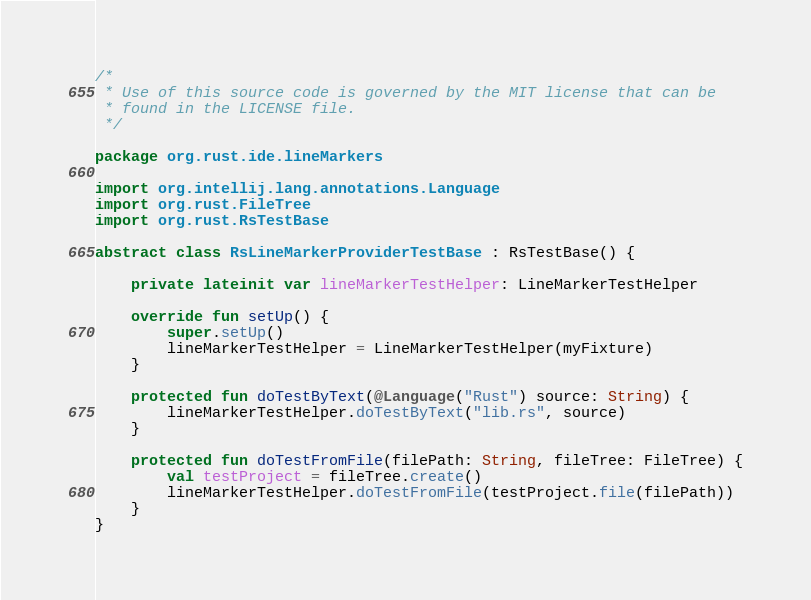Convert code to text. <code><loc_0><loc_0><loc_500><loc_500><_Kotlin_>/*
 * Use of this source code is governed by the MIT license that can be
 * found in the LICENSE file.
 */

package org.rust.ide.lineMarkers

import org.intellij.lang.annotations.Language
import org.rust.FileTree
import org.rust.RsTestBase

abstract class RsLineMarkerProviderTestBase : RsTestBase() {

    private lateinit var lineMarkerTestHelper: LineMarkerTestHelper

    override fun setUp() {
        super.setUp()
        lineMarkerTestHelper = LineMarkerTestHelper(myFixture)
    }

    protected fun doTestByText(@Language("Rust") source: String) {
        lineMarkerTestHelper.doTestByText("lib.rs", source)
    }

    protected fun doTestFromFile(filePath: String, fileTree: FileTree) {
        val testProject = fileTree.create()
        lineMarkerTestHelper.doTestFromFile(testProject.file(filePath))
    }
}
</code> 